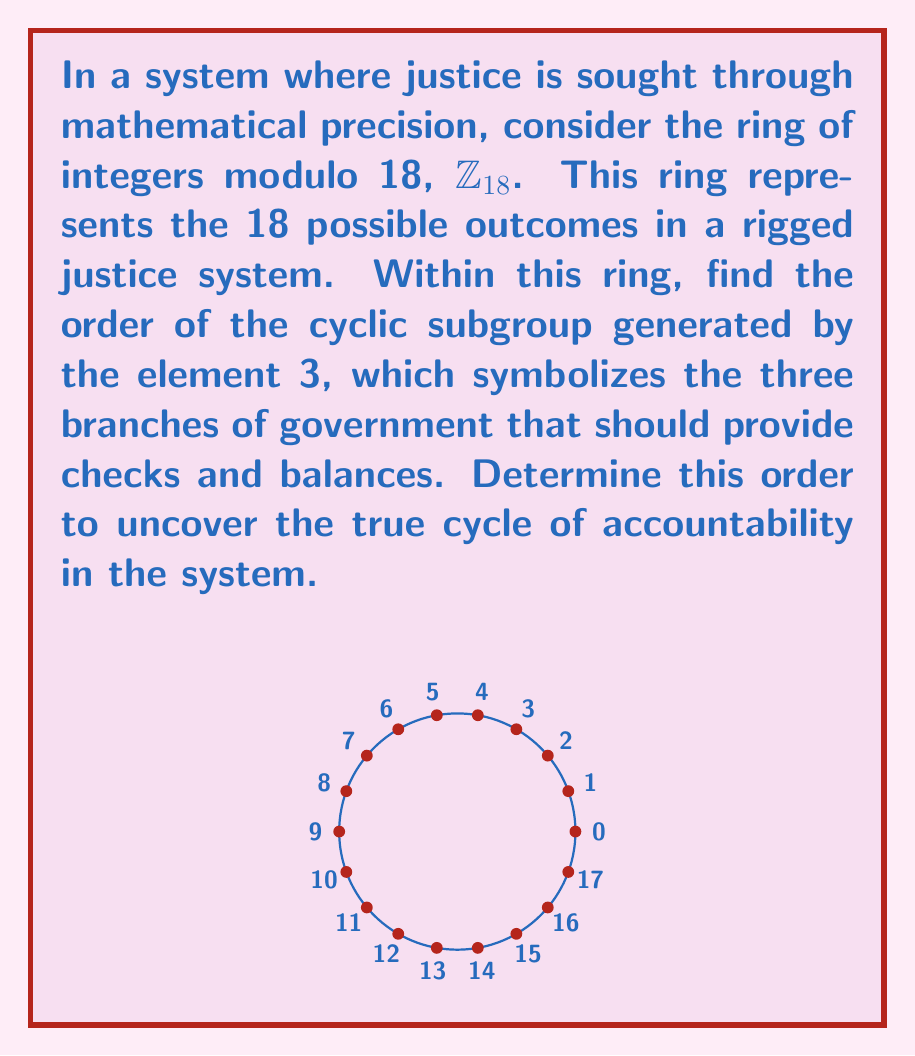Help me with this question. To find the order of the cyclic subgroup generated by 3 in $\mathbb{Z}_{18}$, we need to determine the smallest positive integer $k$ such that $3k \equiv 0 \pmod{18}$. This is equivalent to finding the smallest $k$ where 18 divides $3k$.

Let's calculate the multiples of 3 modulo 18:

1. $3 \cdot 1 \equiv 3 \pmod{18}$
2. $3 \cdot 2 \equiv 6 \pmod{18}$
3. $3 \cdot 3 \equiv 9 \pmod{18}$
4. $3 \cdot 4 \equiv 12 \pmod{18}$
5. $3 \cdot 5 \equiv 15 \pmod{18}$
6. $3 \cdot 6 \equiv 0 \pmod{18}$

We see that when $k=6$, we get $3k \equiv 0 \pmod{18}$. This is the smallest such positive integer.

To verify, we can check that 18 divides $3 \cdot 6 = 18$.

Therefore, the order of the cyclic subgroup generated by 3 in $\mathbb{Z}_{18}$ is 6.

In the context of the justice system metaphor, this result suggests that the cycle of accountability repeats every 6 steps, highlighting potential limitations in the system's ability to provide continuous, non-repeating oversight.
Answer: 6 